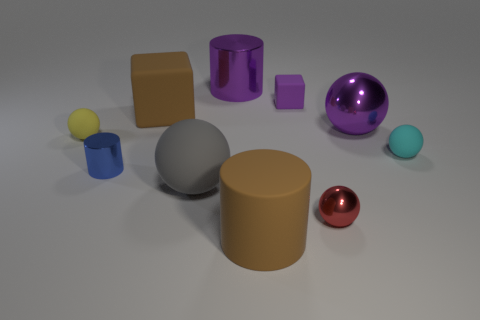Subtract all purple metal cylinders. How many cylinders are left? 2 Subtract all purple spheres. How many spheres are left? 4 Subtract all cubes. How many objects are left? 8 Subtract all gray cylinders. Subtract all green spheres. How many cylinders are left? 3 Subtract all large blue cylinders. Subtract all cylinders. How many objects are left? 7 Add 4 brown matte objects. How many brown matte objects are left? 6 Add 5 small red metallic balls. How many small red metallic balls exist? 6 Subtract 0 gray cubes. How many objects are left? 10 